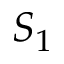<formula> <loc_0><loc_0><loc_500><loc_500>S _ { 1 }</formula> 